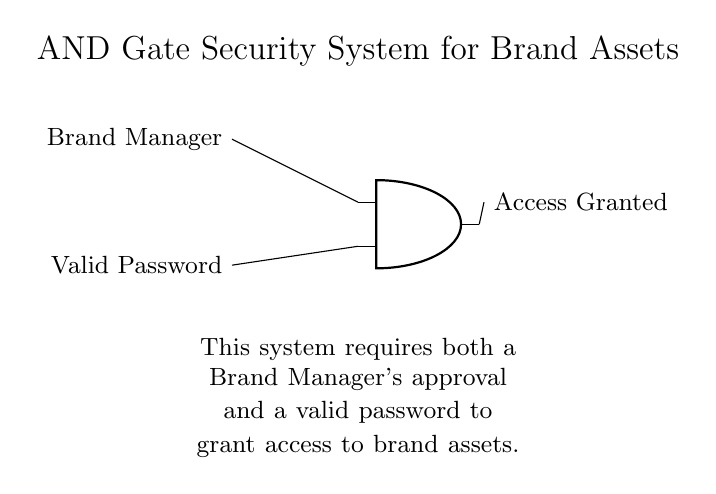What are the two inputs to the AND gate? The two inputs to the AND gate are labeled as "Brand Manager" and "Valid Password" in the circuit diagram.
Answer: Brand Manager, Valid Password What does the output signify when activated? The output of the AND gate indicates "Access Granted" when both inputs are validated, meaning both conditions are met.
Answer: Access Granted Which component type is used in the security system? The diagram uses an AND gate as the fundamental component of the security system, demonstrating a logical conjunction requirement.
Answer: AND gate What is needed for access to brand assets? Access to brand assets requires both a Brand Manager's approval and a valid password, as indicated by the circuit's description and function.
Answer: Both inputs Explain the significance of the AND logic in this context. The AND logic signifies that access will only be granted when both conditions (approval and password) are true or right, preventing unauthorized access.
Answer: Only with both conditions What happens if either input is not valid? If either the Brand Manager's approval or the Valid Password is not provided, the output will not signal "Access Granted," thereby denying access.
Answer: Access Denied 